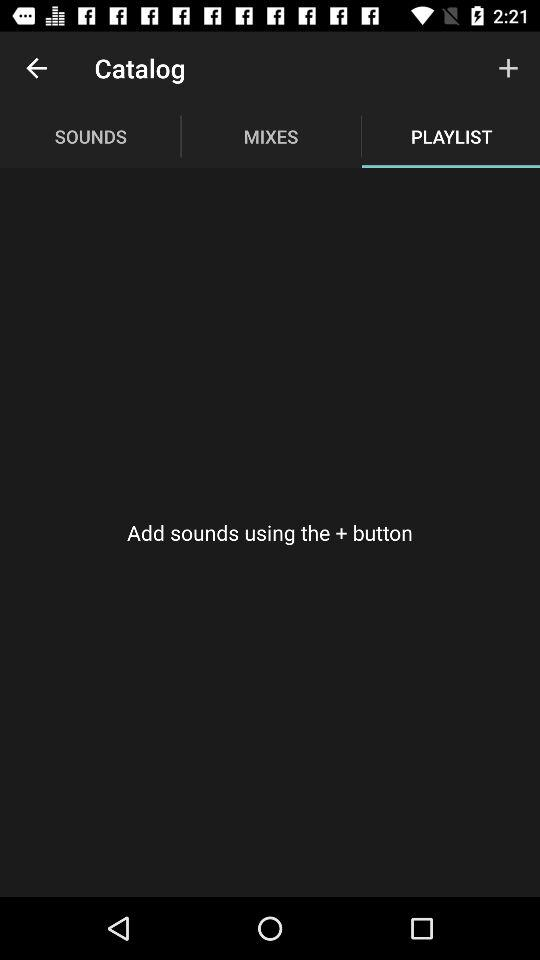Which tab is selected? The selected tab is "PLAYLIST". 